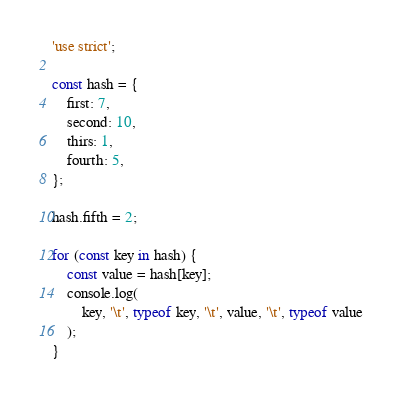<code> <loc_0><loc_0><loc_500><loc_500><_JavaScript_>'use strict';

const hash = {
    first: 7,
    second: 10,
    thirs: 1,
    fourth: 5,
};

hash.fifth = 2;

for (const key in hash) {
    const value = hash[key];
    console.log(
        key, '\t', typeof key, '\t', value, '\t', typeof value
    );
}</code> 